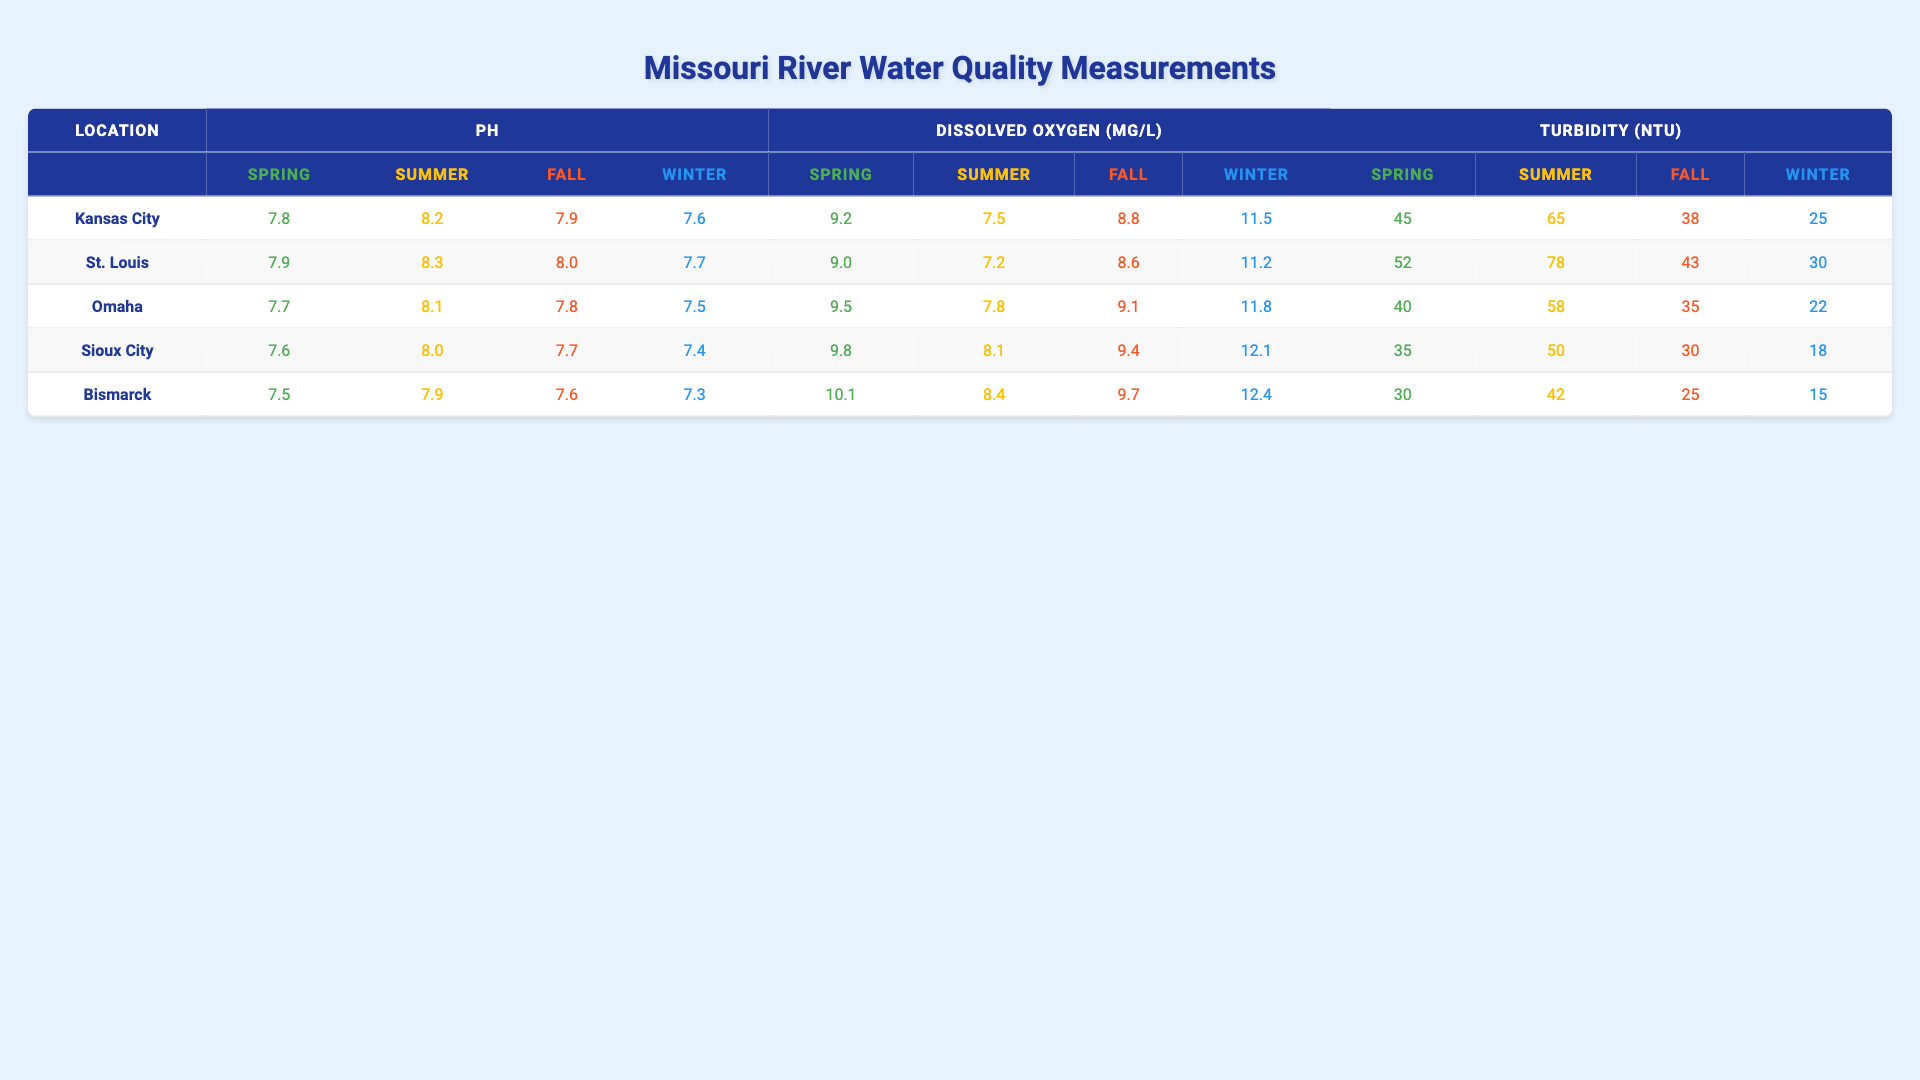What's the pH level of the Missouri River in Kansas City during Summer? Referring to the Kansas City section in the table, the Summer pH measurement is 8.2.
Answer: 8.2 Which location had the highest Dissolved Oxygen level in Winter? Looking at the Winter row for Dissolved Oxygen across all locations, Bismarck has the highest level at 12.4 mg/L.
Answer: Bismarck What is the average Turbidity for the Fall across all locations? The Fall Turbidity values are 38 (Kansas City) + 43 (St. Louis) + 35 (Omaha) + 30 (Sioux City) + 25 (Bismarck) = 171. Then, divide by 5 locations: 171 / 5 = 34.2
Answer: 34.2 Did the Dissolved Oxygen level in Omaha increase from Spring to Summer? In Spring, Omaha's Dissolved Oxygen is 9.5 mg/L and in Summer, it's 7.8 mg/L. Since 9.5 > 7.8, the level decreased.
Answer: No Which season showed the lowest pH level across all locations? By checking the pH levels for each location: Kansas City (Winter 7.6), St. Louis (Winter 7.7), Omaha (Winter 7.5), Sioux City (Winter 7.4), Bismarck (Winter 7.3), Winter shows the lowest at 7.3 in Bismarck.
Answer: Winter What is the difference in Turbidity between Spring and Summer for Sioux City? Sioux City’s Spring Turbidity is 35 NTU and Summer Turbidity is 50 NTU. The difference is 50 - 35 = 15 NTU.
Answer: 15 NTU Is the pH level in Bismarck during Spring higher than in Omaha during Summer? Bismarck's Spring pH is 7.5, while Omaha's Summer pH is 8.1. Since 7.5 < 8.1, the statement is false.
Answer: No Which location experienced the largest decrease in Dissolved Oxygen from Spring to Summer? For Kansas City: 9.2 to 7.5 (decrease of 1.7), St. Louis: 9.0 to 7.2 (decrease of 1.8), Omaha: 9.5 to 7.8 (decrease of 1.7), Sioux City: 9.8 to 8.1 (decrease of 1.7), Bismarck: 10.1 to 8.4 (decrease of 1.7). St. Louis has the largest decrease of 1.8.
Answer: St. Louis What was the average pH level across all locations in Spring? The Spring pH values are: 7.8 (Kansas City), 7.9 (St. Louis), 7.7 (Omaha), 7.6 (Sioux City), 7.5 (Bismarck). Their sum (7.8 + 7.9 + 7.7 + 7.6 + 7.5 = 38.5) divided by 5 equals 7.7.
Answer: 7.7 In which season is the Turbidity level in Kansas City the lowest? By examining the Turbidity values: 45 (Spring), 65 (Summer), 38 (Fall), 25 (Winter), Kansas City has the lowest Turbidity during Winter at 25 NTU.
Answer: Winter 